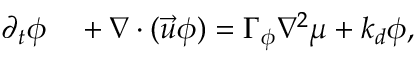Convert formula to latex. <formula><loc_0><loc_0><loc_500><loc_500>\begin{array} { r l } { \partial _ { t } \phi } & + \nabla \cdot ( \vec { u } \phi ) = \Gamma _ { \phi } \nabla ^ { 2 } \mu + k _ { d } \phi , } \end{array}</formula> 